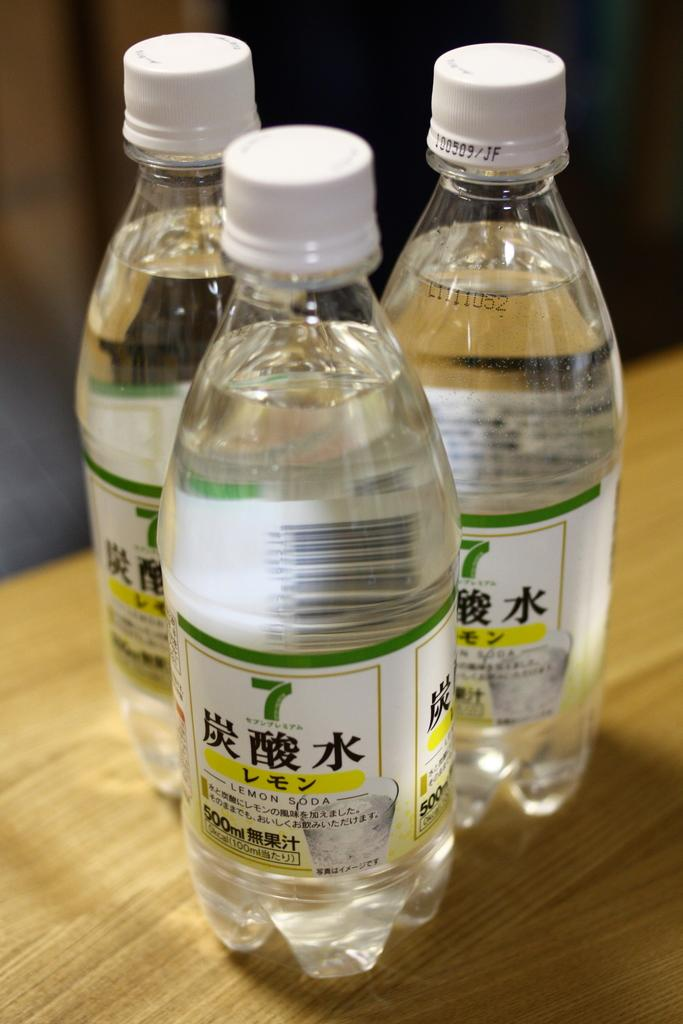Provide a one-sentence caption for the provided image. Bottles of Lemon Soda sitting on a table 500 ml each. 